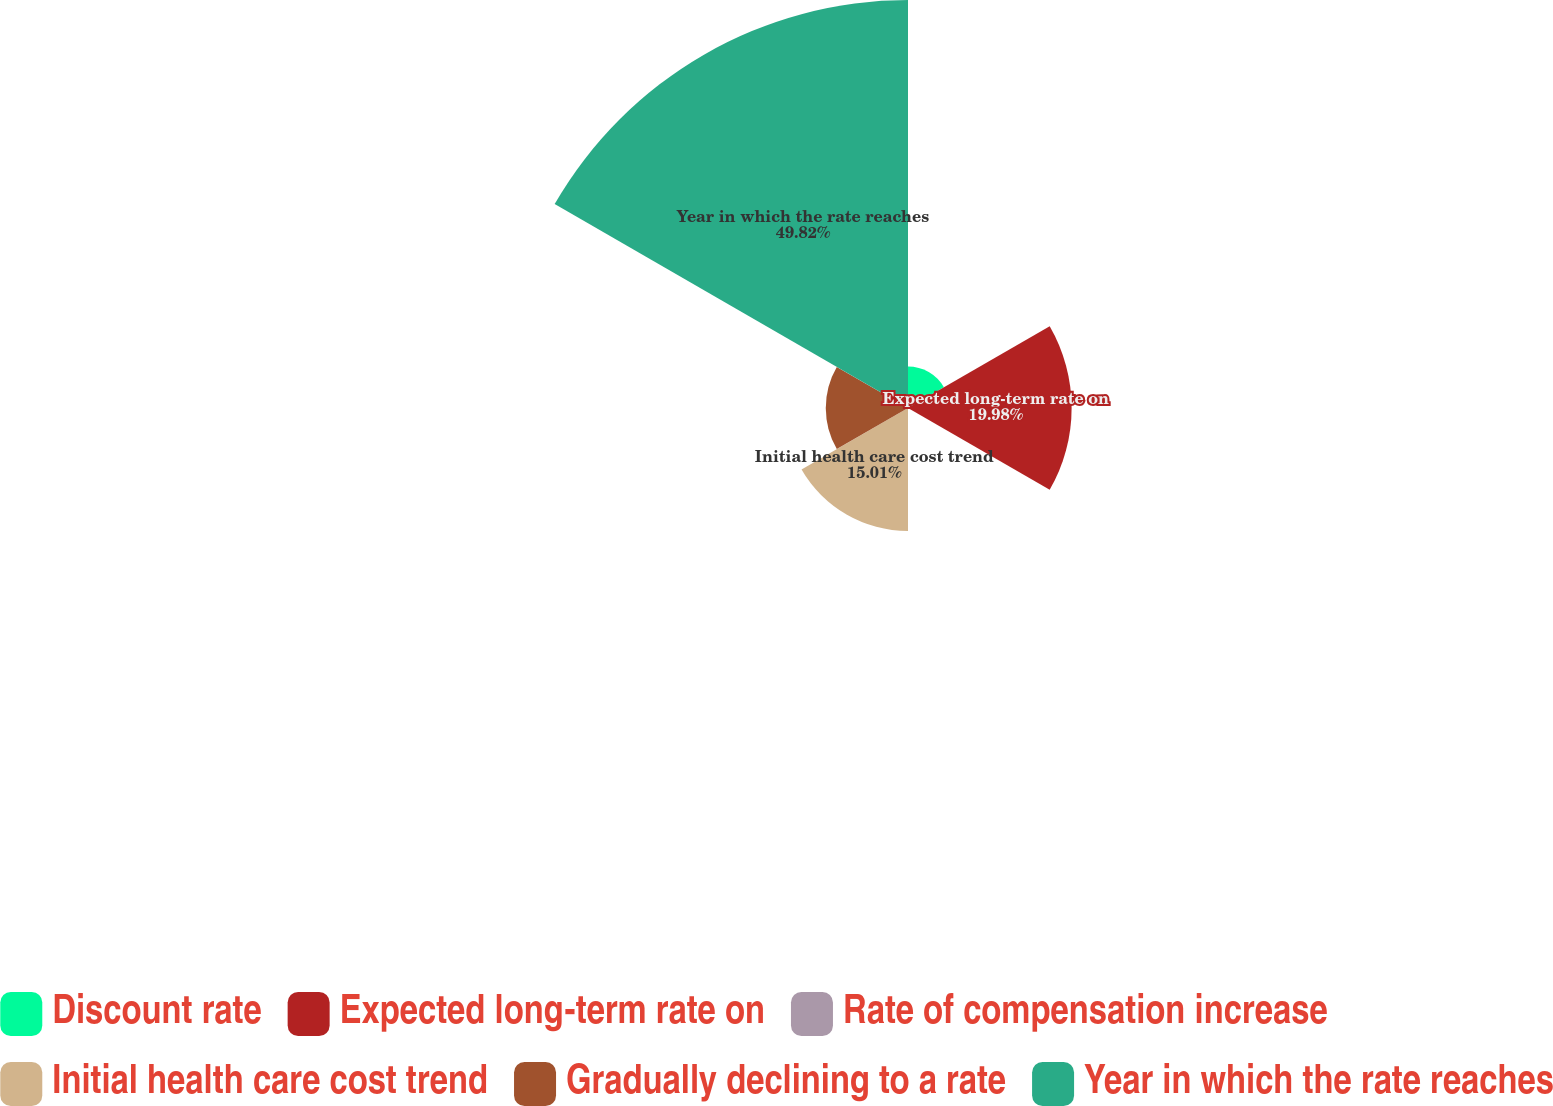Convert chart. <chart><loc_0><loc_0><loc_500><loc_500><pie_chart><fcel>Discount rate<fcel>Expected long-term rate on<fcel>Rate of compensation increase<fcel>Initial health care cost trend<fcel>Gradually declining to a rate<fcel>Year in which the rate reaches<nl><fcel>5.06%<fcel>19.98%<fcel>0.09%<fcel>15.01%<fcel>10.04%<fcel>49.82%<nl></chart> 